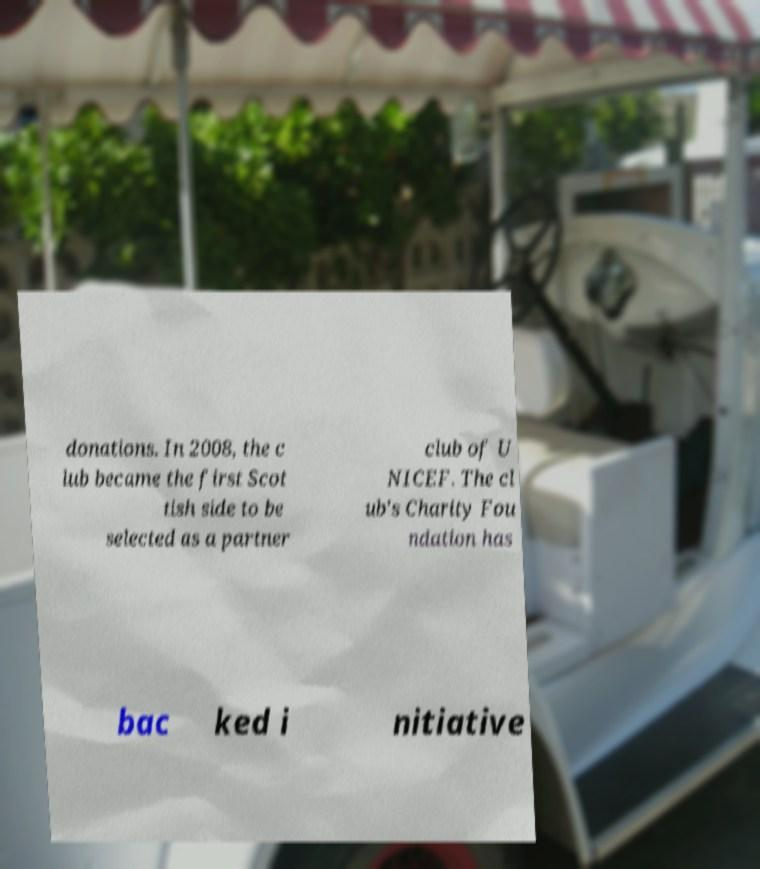Can you accurately transcribe the text from the provided image for me? donations. In 2008, the c lub became the first Scot tish side to be selected as a partner club of U NICEF. The cl ub's Charity Fou ndation has bac ked i nitiative 